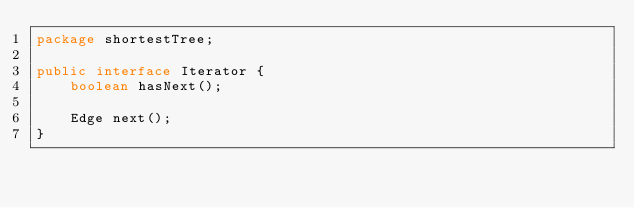Convert code to text. <code><loc_0><loc_0><loc_500><loc_500><_Java_>package shortestTree;

public interface Iterator {
    boolean hasNext();

    Edge next();
}
</code> 